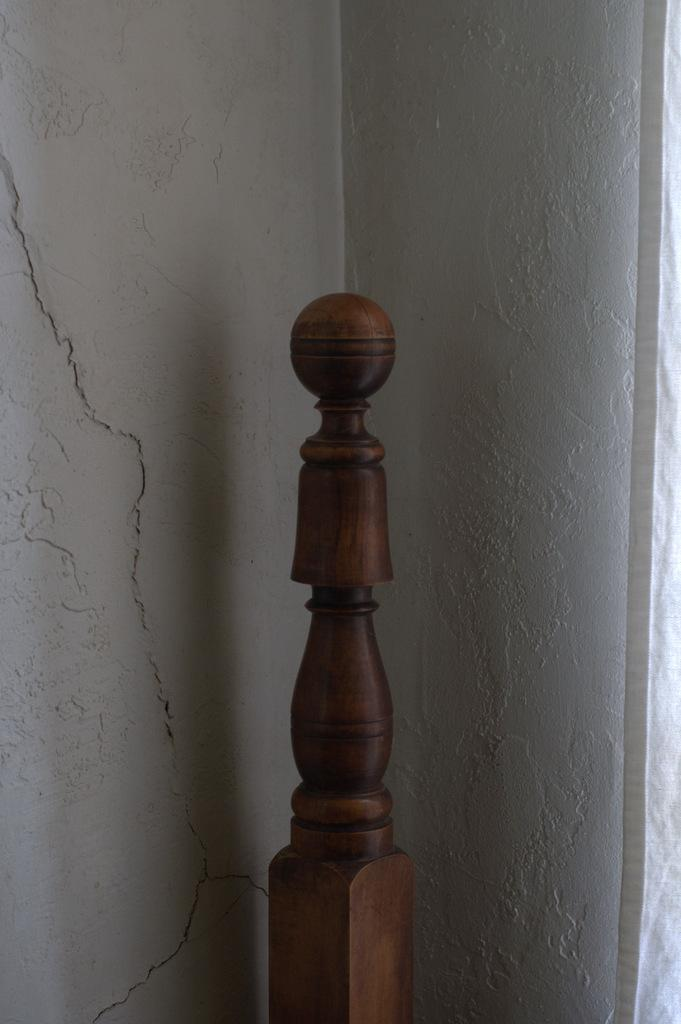What type of structure is present in the image? There is a wooden balustrade in the image. What is the color of the balustrade? The balustrade is brown in color. What can be seen in the background of the image? There is a wall in the background of the image. What is the color of the wall? The wall is white in color. Where is the hydrant located in the image? There is no hydrant present in the image. What type of flock is visible in the image? There is no flock visible in the image. 